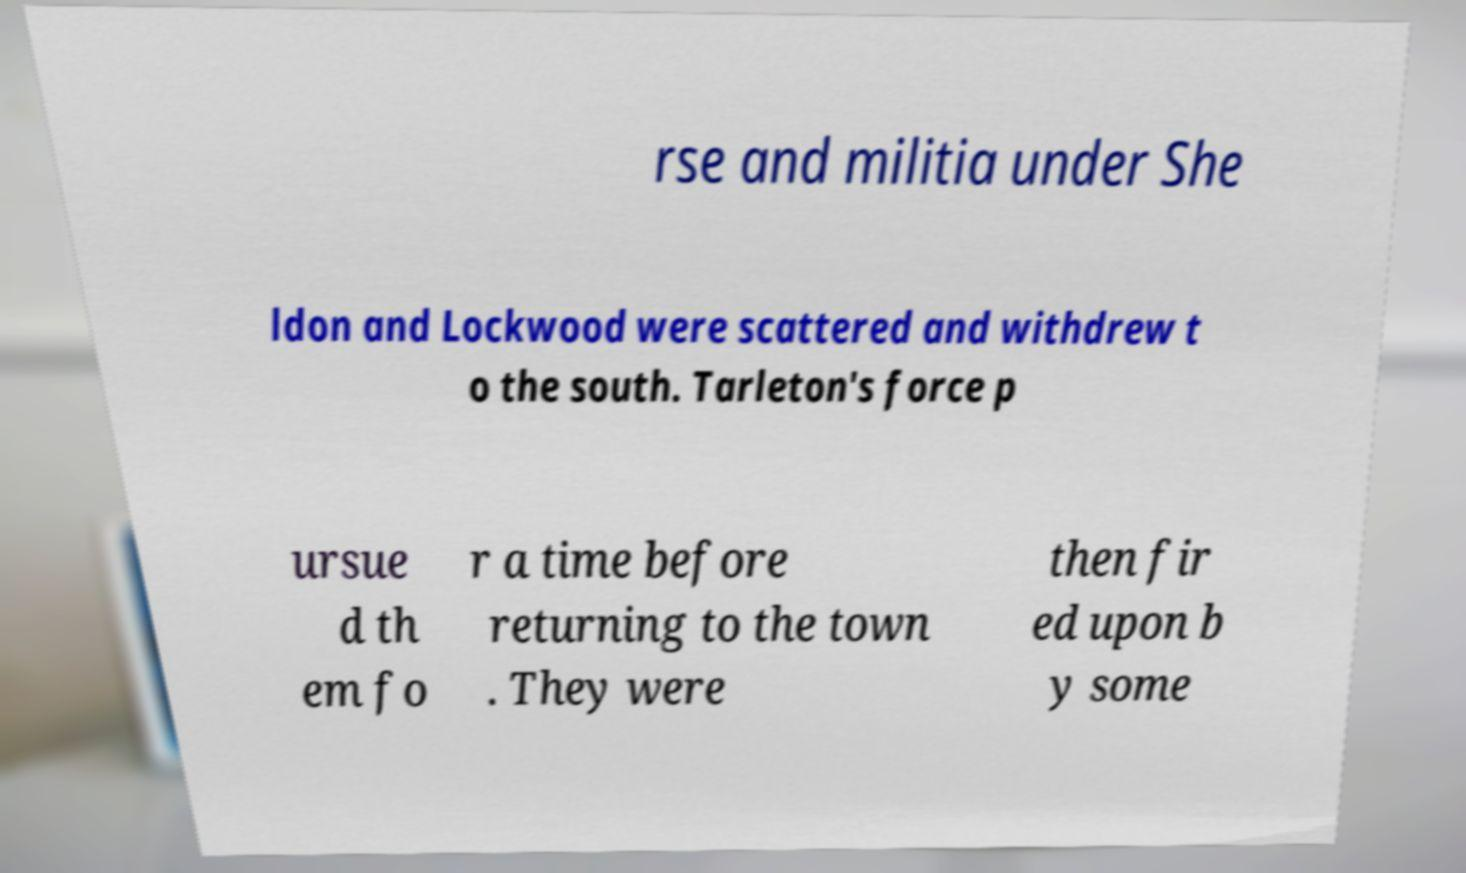Could you extract and type out the text from this image? rse and militia under She ldon and Lockwood were scattered and withdrew t o the south. Tarleton's force p ursue d th em fo r a time before returning to the town . They were then fir ed upon b y some 